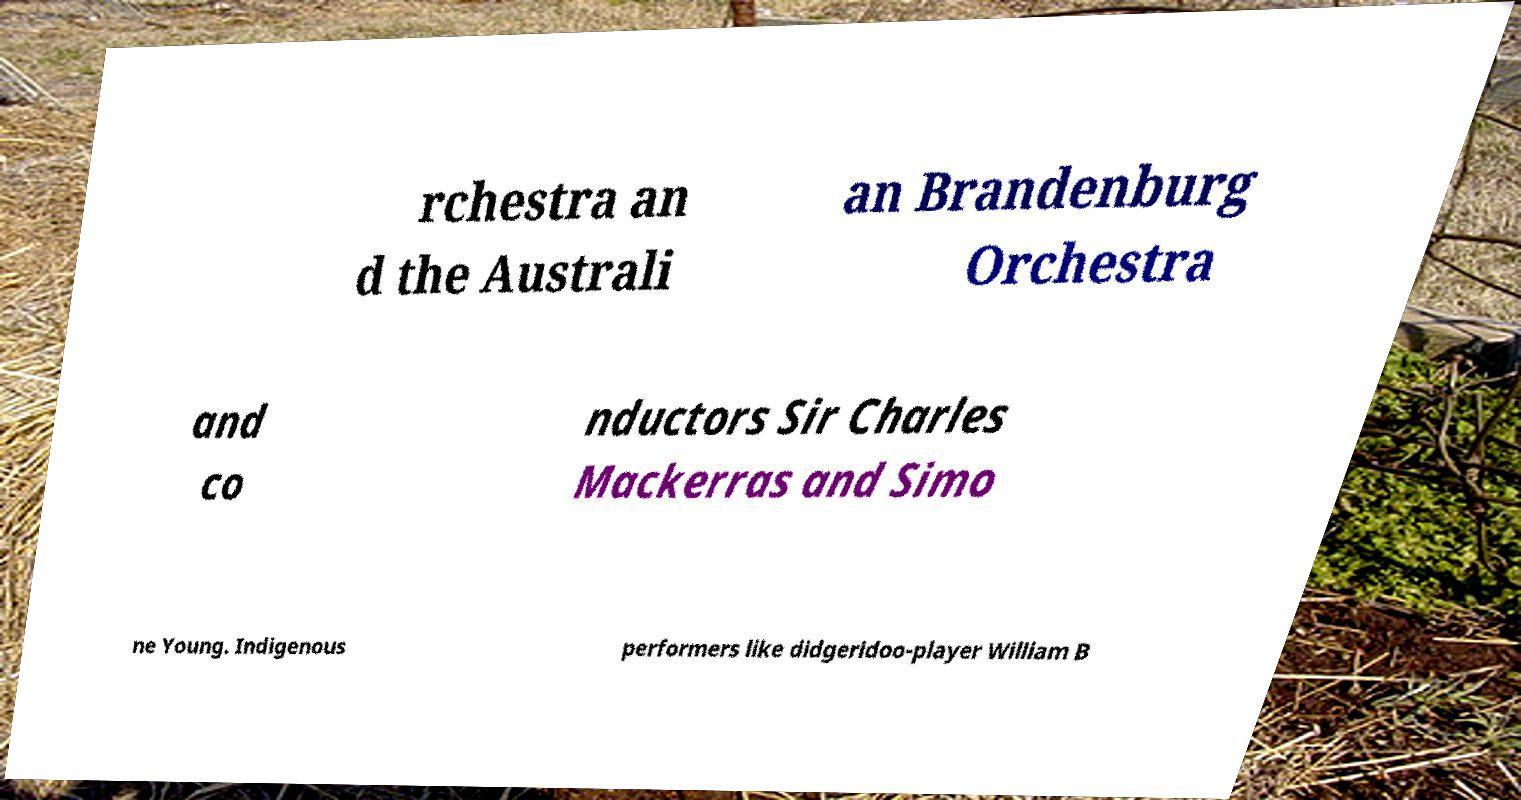Could you extract and type out the text from this image? rchestra an d the Australi an Brandenburg Orchestra and co nductors Sir Charles Mackerras and Simo ne Young. Indigenous performers like didgeridoo-player William B 